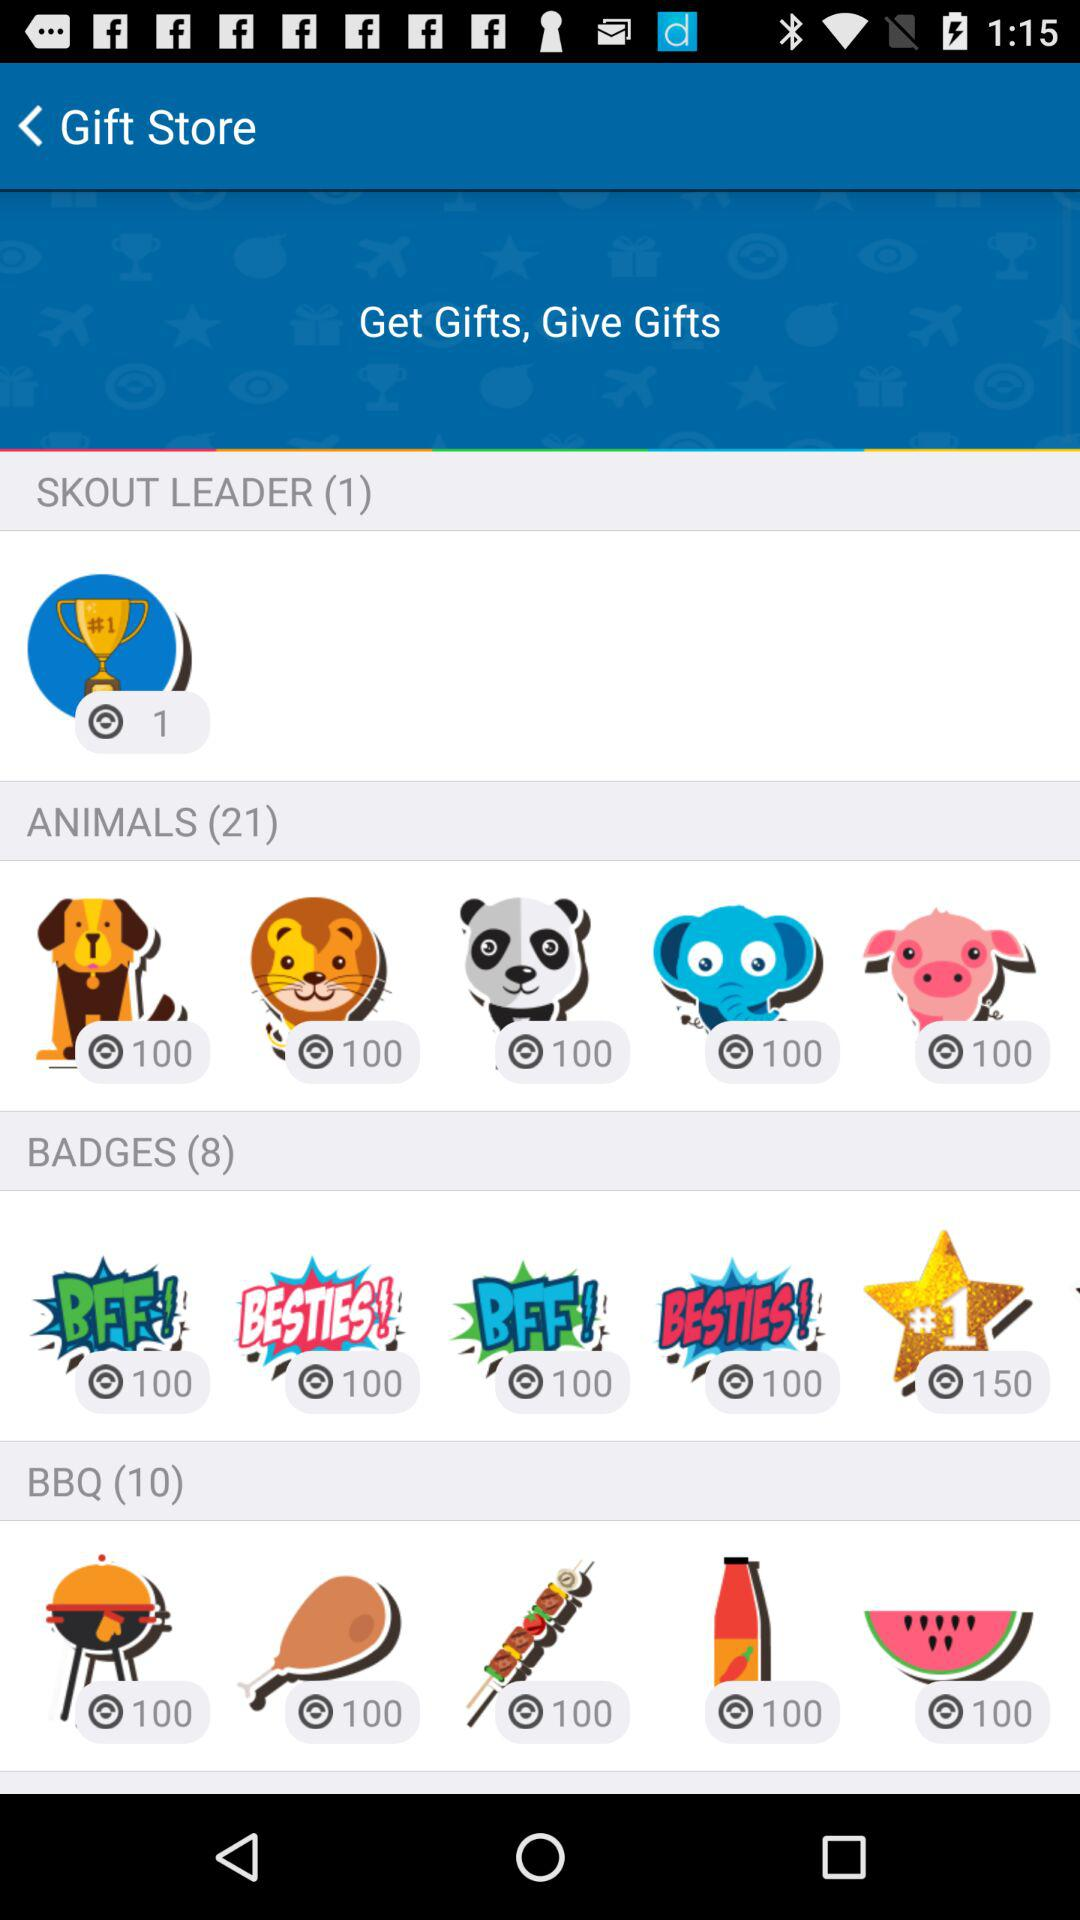What is the total number of animals? The total number of animals is 21. 